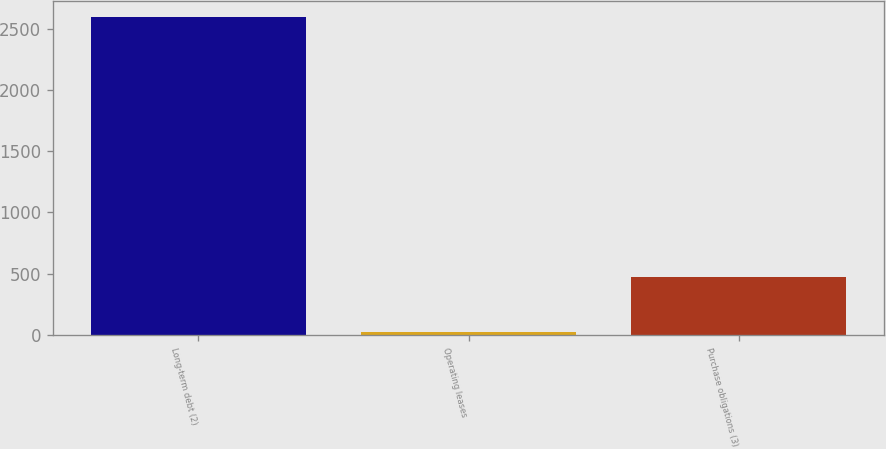<chart> <loc_0><loc_0><loc_500><loc_500><bar_chart><fcel>Long-term debt (2)<fcel>Operating leases<fcel>Purchase obligations (3)<nl><fcel>2595<fcel>19<fcel>471<nl></chart> 